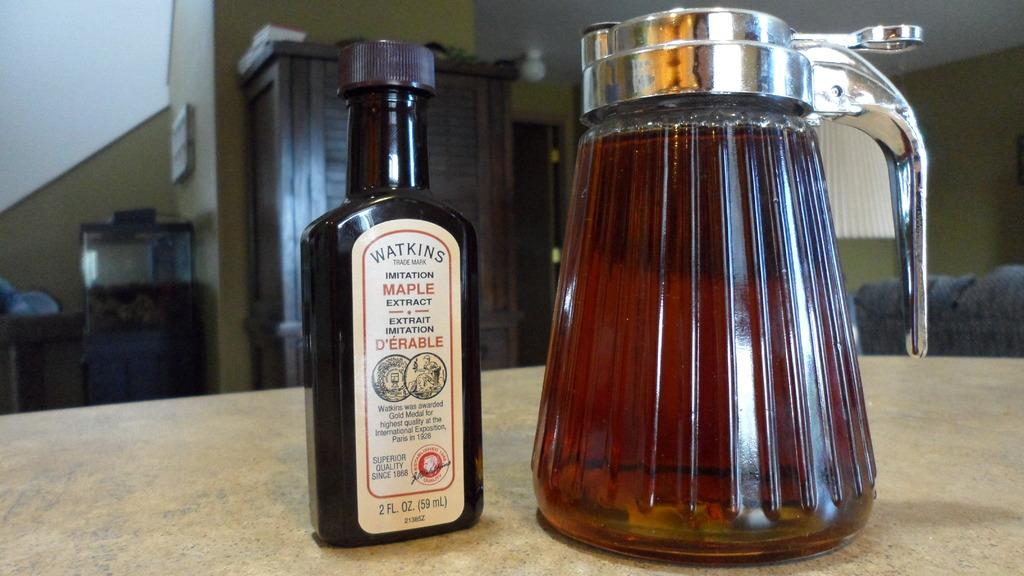<image>
Share a concise interpretation of the image provided. A bottle of Watkins maple extract next to a syrup container. 